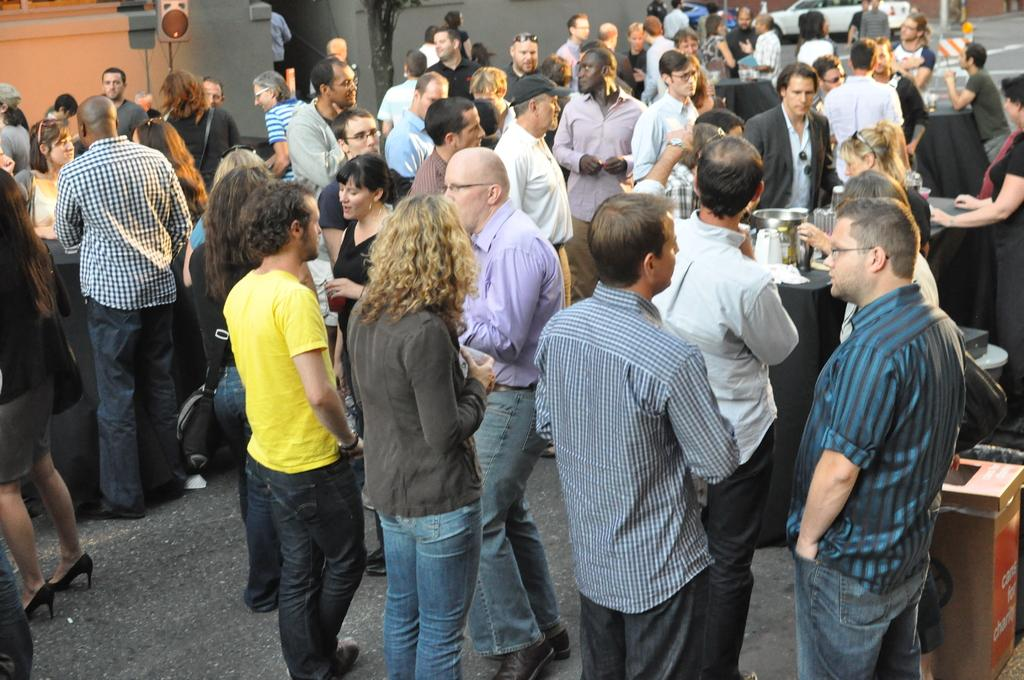How many people are in the group visible in the image? The facts provided do not specify the number of people in the group, so we cannot definitively answer this question. What type of vehicles can be seen on the road in the image? The facts provided do not specify the type of vehicles on the road, so we cannot definitively answer this question. What color is the yak's powder on the face of the person in the image? There is no yak, powder, or face visible in the image. 